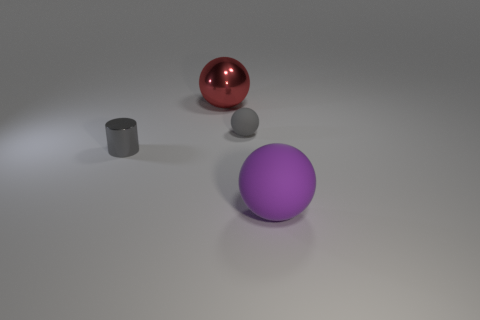Subtract all small gray balls. How many balls are left? 2 Subtract 1 balls. How many balls are left? 2 Add 3 tiny red metallic things. How many objects exist? 7 Add 1 large yellow objects. How many large yellow objects exist? 1 Subtract 0 brown cylinders. How many objects are left? 4 Subtract all cylinders. How many objects are left? 3 Subtract all small blue matte objects. Subtract all gray spheres. How many objects are left? 3 Add 4 big purple objects. How many big purple objects are left? 5 